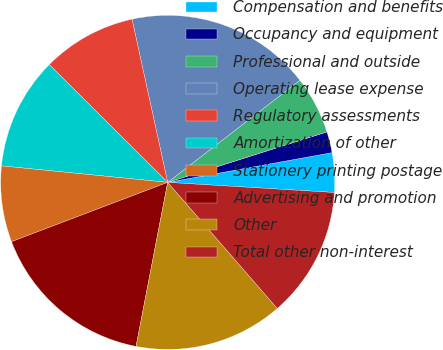<chart> <loc_0><loc_0><loc_500><loc_500><pie_chart><fcel>Compensation and benefits<fcel>Occupancy and equipment<fcel>Professional and outside<fcel>Operating lease expense<fcel>Regulatory assessments<fcel>Amortization of other<fcel>Stationery printing postage<fcel>Advertising and promotion<fcel>Other<fcel>Total other non-interest<nl><fcel>3.81%<fcel>2.04%<fcel>5.58%<fcel>17.96%<fcel>9.12%<fcel>10.88%<fcel>7.35%<fcel>16.19%<fcel>14.42%<fcel>12.65%<nl></chart> 